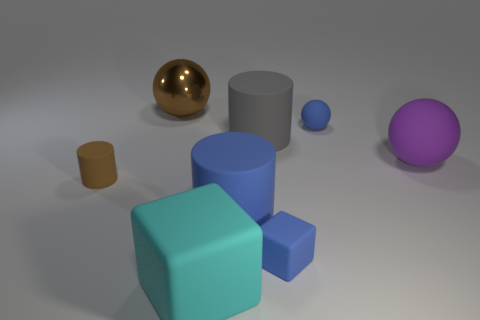There is a blue rubber thing that is behind the brown object in front of the purple sphere; how big is it?
Offer a very short reply. Small. There is a brown object in front of the sphere on the left side of the tiny blue object in front of the large purple matte object; what shape is it?
Your answer should be compact. Cylinder. What color is the tiny cube that is made of the same material as the large cyan cube?
Your answer should be very brief. Blue. The thing on the left side of the large thing that is to the left of the block that is left of the big gray rubber object is what color?
Give a very brief answer. Brown. How many cylinders are either tiny blue matte objects or purple matte things?
Your answer should be very brief. 0. There is a tiny object that is the same color as the tiny rubber cube; what is it made of?
Your answer should be compact. Rubber. There is a tiny matte cylinder; does it have the same color as the big metal ball behind the large purple matte thing?
Offer a terse response. Yes. The metallic ball has what color?
Provide a succinct answer. Brown. How many things are large yellow cylinders or brown metal things?
Your answer should be compact. 1. There is a brown ball that is the same size as the blue rubber cylinder; what is its material?
Offer a very short reply. Metal. 